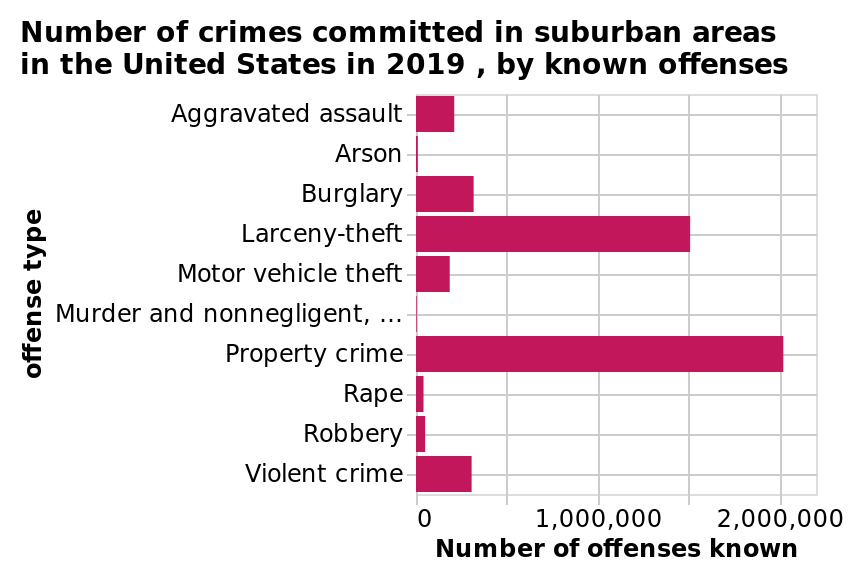<image>
What does the x-axis of the graph indicate?  The x-axis of the graph indicates the number of offenses known. Which type of crime has the lowest number of known offenses? Arson and murder have the lowest number of known offenses. What is the title of the bar graph?  The title of the bar graph is "Number of crimes committed in suburban areas in the United States in 2019, by known offenses." Does the y-axis of the graph indicate the number of offenses known? No. The x-axis of the graph indicates the number of offenses known. 